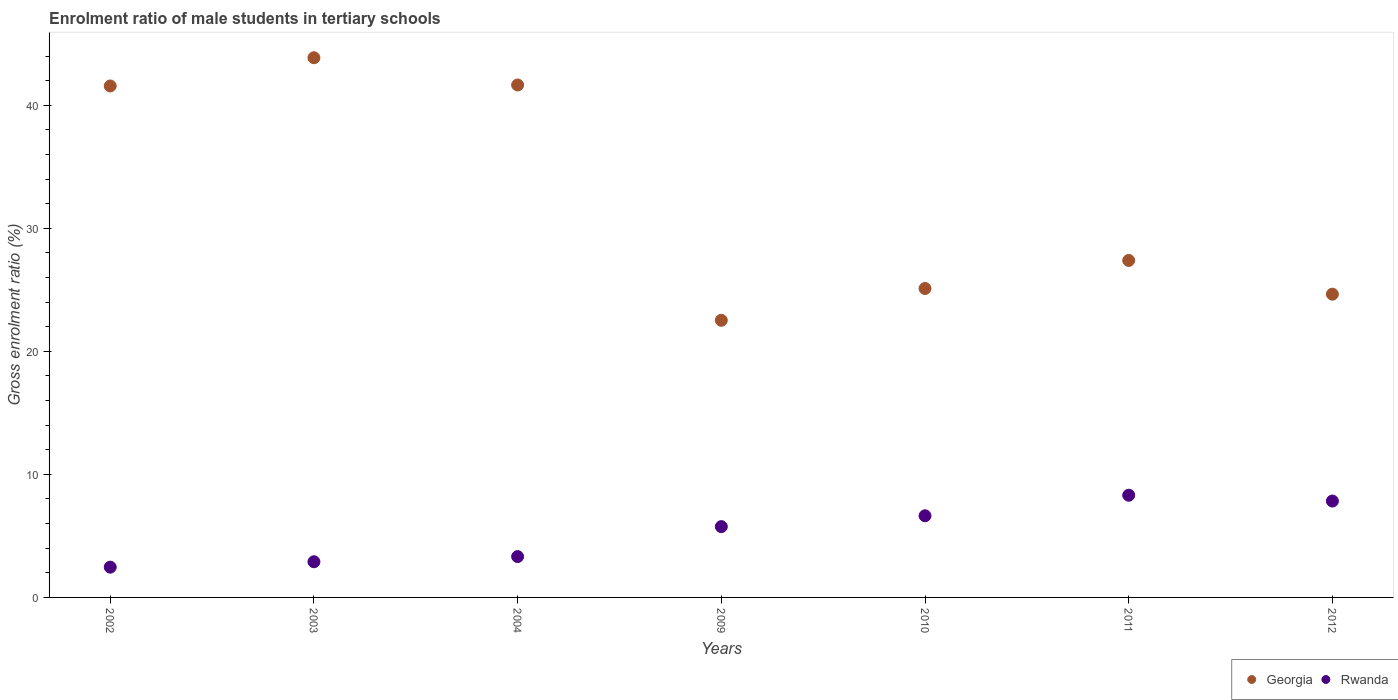How many different coloured dotlines are there?
Your answer should be compact. 2. What is the enrolment ratio of male students in tertiary schools in Rwanda in 2012?
Ensure brevity in your answer.  7.83. Across all years, what is the maximum enrolment ratio of male students in tertiary schools in Georgia?
Your answer should be compact. 43.86. Across all years, what is the minimum enrolment ratio of male students in tertiary schools in Rwanda?
Keep it short and to the point. 2.46. In which year was the enrolment ratio of male students in tertiary schools in Rwanda maximum?
Your answer should be compact. 2011. What is the total enrolment ratio of male students in tertiary schools in Georgia in the graph?
Make the answer very short. 226.74. What is the difference between the enrolment ratio of male students in tertiary schools in Georgia in 2010 and that in 2012?
Make the answer very short. 0.46. What is the difference between the enrolment ratio of male students in tertiary schools in Georgia in 2010 and the enrolment ratio of male students in tertiary schools in Rwanda in 2012?
Ensure brevity in your answer.  17.27. What is the average enrolment ratio of male students in tertiary schools in Georgia per year?
Offer a very short reply. 32.39. In the year 2011, what is the difference between the enrolment ratio of male students in tertiary schools in Rwanda and enrolment ratio of male students in tertiary schools in Georgia?
Keep it short and to the point. -19.08. In how many years, is the enrolment ratio of male students in tertiary schools in Georgia greater than 34 %?
Your response must be concise. 3. What is the ratio of the enrolment ratio of male students in tertiary schools in Georgia in 2003 to that in 2011?
Provide a short and direct response. 1.6. Is the enrolment ratio of male students in tertiary schools in Rwanda in 2003 less than that in 2012?
Provide a succinct answer. Yes. What is the difference between the highest and the second highest enrolment ratio of male students in tertiary schools in Georgia?
Your response must be concise. 2.22. What is the difference between the highest and the lowest enrolment ratio of male students in tertiary schools in Georgia?
Provide a short and direct response. 21.34. Is the enrolment ratio of male students in tertiary schools in Rwanda strictly less than the enrolment ratio of male students in tertiary schools in Georgia over the years?
Offer a terse response. Yes. How many dotlines are there?
Your response must be concise. 2. Are the values on the major ticks of Y-axis written in scientific E-notation?
Ensure brevity in your answer.  No. Does the graph contain grids?
Provide a succinct answer. No. Where does the legend appear in the graph?
Give a very brief answer. Bottom right. How many legend labels are there?
Provide a short and direct response. 2. What is the title of the graph?
Ensure brevity in your answer.  Enrolment ratio of male students in tertiary schools. Does "Tuvalu" appear as one of the legend labels in the graph?
Offer a terse response. No. What is the label or title of the X-axis?
Offer a terse response. Years. What is the label or title of the Y-axis?
Make the answer very short. Gross enrolment ratio (%). What is the Gross enrolment ratio (%) of Georgia in 2002?
Provide a short and direct response. 41.57. What is the Gross enrolment ratio (%) of Rwanda in 2002?
Provide a succinct answer. 2.46. What is the Gross enrolment ratio (%) of Georgia in 2003?
Give a very brief answer. 43.86. What is the Gross enrolment ratio (%) of Rwanda in 2003?
Your response must be concise. 2.9. What is the Gross enrolment ratio (%) in Georgia in 2004?
Offer a very short reply. 41.65. What is the Gross enrolment ratio (%) in Rwanda in 2004?
Offer a terse response. 3.32. What is the Gross enrolment ratio (%) in Georgia in 2009?
Provide a short and direct response. 22.52. What is the Gross enrolment ratio (%) of Rwanda in 2009?
Provide a succinct answer. 5.75. What is the Gross enrolment ratio (%) of Georgia in 2010?
Provide a short and direct response. 25.11. What is the Gross enrolment ratio (%) in Rwanda in 2010?
Provide a short and direct response. 6.64. What is the Gross enrolment ratio (%) of Georgia in 2011?
Give a very brief answer. 27.39. What is the Gross enrolment ratio (%) of Rwanda in 2011?
Your answer should be compact. 8.31. What is the Gross enrolment ratio (%) of Georgia in 2012?
Make the answer very short. 24.65. What is the Gross enrolment ratio (%) of Rwanda in 2012?
Ensure brevity in your answer.  7.83. Across all years, what is the maximum Gross enrolment ratio (%) of Georgia?
Provide a short and direct response. 43.86. Across all years, what is the maximum Gross enrolment ratio (%) in Rwanda?
Make the answer very short. 8.31. Across all years, what is the minimum Gross enrolment ratio (%) in Georgia?
Your response must be concise. 22.52. Across all years, what is the minimum Gross enrolment ratio (%) of Rwanda?
Ensure brevity in your answer.  2.46. What is the total Gross enrolment ratio (%) of Georgia in the graph?
Give a very brief answer. 226.74. What is the total Gross enrolment ratio (%) of Rwanda in the graph?
Give a very brief answer. 37.21. What is the difference between the Gross enrolment ratio (%) in Georgia in 2002 and that in 2003?
Your response must be concise. -2.3. What is the difference between the Gross enrolment ratio (%) in Rwanda in 2002 and that in 2003?
Your response must be concise. -0.44. What is the difference between the Gross enrolment ratio (%) in Georgia in 2002 and that in 2004?
Your answer should be very brief. -0.08. What is the difference between the Gross enrolment ratio (%) in Rwanda in 2002 and that in 2004?
Provide a short and direct response. -0.86. What is the difference between the Gross enrolment ratio (%) in Georgia in 2002 and that in 2009?
Make the answer very short. 19.04. What is the difference between the Gross enrolment ratio (%) in Rwanda in 2002 and that in 2009?
Provide a short and direct response. -3.29. What is the difference between the Gross enrolment ratio (%) in Georgia in 2002 and that in 2010?
Provide a succinct answer. 16.46. What is the difference between the Gross enrolment ratio (%) of Rwanda in 2002 and that in 2010?
Offer a terse response. -4.17. What is the difference between the Gross enrolment ratio (%) of Georgia in 2002 and that in 2011?
Provide a succinct answer. 14.18. What is the difference between the Gross enrolment ratio (%) of Rwanda in 2002 and that in 2011?
Your answer should be compact. -5.85. What is the difference between the Gross enrolment ratio (%) of Georgia in 2002 and that in 2012?
Provide a succinct answer. 16.92. What is the difference between the Gross enrolment ratio (%) of Rwanda in 2002 and that in 2012?
Offer a very short reply. -5.37. What is the difference between the Gross enrolment ratio (%) in Georgia in 2003 and that in 2004?
Give a very brief answer. 2.22. What is the difference between the Gross enrolment ratio (%) of Rwanda in 2003 and that in 2004?
Ensure brevity in your answer.  -0.42. What is the difference between the Gross enrolment ratio (%) in Georgia in 2003 and that in 2009?
Give a very brief answer. 21.34. What is the difference between the Gross enrolment ratio (%) in Rwanda in 2003 and that in 2009?
Give a very brief answer. -2.86. What is the difference between the Gross enrolment ratio (%) in Georgia in 2003 and that in 2010?
Keep it short and to the point. 18.76. What is the difference between the Gross enrolment ratio (%) of Rwanda in 2003 and that in 2010?
Your response must be concise. -3.74. What is the difference between the Gross enrolment ratio (%) of Georgia in 2003 and that in 2011?
Ensure brevity in your answer.  16.47. What is the difference between the Gross enrolment ratio (%) of Rwanda in 2003 and that in 2011?
Your answer should be very brief. -5.41. What is the difference between the Gross enrolment ratio (%) in Georgia in 2003 and that in 2012?
Give a very brief answer. 19.22. What is the difference between the Gross enrolment ratio (%) in Rwanda in 2003 and that in 2012?
Provide a short and direct response. -4.93. What is the difference between the Gross enrolment ratio (%) of Georgia in 2004 and that in 2009?
Keep it short and to the point. 19.12. What is the difference between the Gross enrolment ratio (%) in Rwanda in 2004 and that in 2009?
Make the answer very short. -2.44. What is the difference between the Gross enrolment ratio (%) in Georgia in 2004 and that in 2010?
Provide a succinct answer. 16.54. What is the difference between the Gross enrolment ratio (%) of Rwanda in 2004 and that in 2010?
Offer a terse response. -3.32. What is the difference between the Gross enrolment ratio (%) in Georgia in 2004 and that in 2011?
Your answer should be very brief. 14.26. What is the difference between the Gross enrolment ratio (%) in Rwanda in 2004 and that in 2011?
Provide a short and direct response. -4.99. What is the difference between the Gross enrolment ratio (%) of Georgia in 2004 and that in 2012?
Offer a very short reply. 17. What is the difference between the Gross enrolment ratio (%) in Rwanda in 2004 and that in 2012?
Your answer should be compact. -4.51. What is the difference between the Gross enrolment ratio (%) of Georgia in 2009 and that in 2010?
Give a very brief answer. -2.58. What is the difference between the Gross enrolment ratio (%) of Rwanda in 2009 and that in 2010?
Give a very brief answer. -0.88. What is the difference between the Gross enrolment ratio (%) in Georgia in 2009 and that in 2011?
Provide a succinct answer. -4.86. What is the difference between the Gross enrolment ratio (%) in Rwanda in 2009 and that in 2011?
Ensure brevity in your answer.  -2.55. What is the difference between the Gross enrolment ratio (%) of Georgia in 2009 and that in 2012?
Give a very brief answer. -2.12. What is the difference between the Gross enrolment ratio (%) of Rwanda in 2009 and that in 2012?
Keep it short and to the point. -2.08. What is the difference between the Gross enrolment ratio (%) of Georgia in 2010 and that in 2011?
Your answer should be very brief. -2.28. What is the difference between the Gross enrolment ratio (%) of Rwanda in 2010 and that in 2011?
Keep it short and to the point. -1.67. What is the difference between the Gross enrolment ratio (%) in Georgia in 2010 and that in 2012?
Your response must be concise. 0.46. What is the difference between the Gross enrolment ratio (%) in Rwanda in 2010 and that in 2012?
Your answer should be very brief. -1.2. What is the difference between the Gross enrolment ratio (%) of Georgia in 2011 and that in 2012?
Your answer should be compact. 2.74. What is the difference between the Gross enrolment ratio (%) of Rwanda in 2011 and that in 2012?
Offer a very short reply. 0.47. What is the difference between the Gross enrolment ratio (%) in Georgia in 2002 and the Gross enrolment ratio (%) in Rwanda in 2003?
Keep it short and to the point. 38.67. What is the difference between the Gross enrolment ratio (%) in Georgia in 2002 and the Gross enrolment ratio (%) in Rwanda in 2004?
Your answer should be very brief. 38.25. What is the difference between the Gross enrolment ratio (%) in Georgia in 2002 and the Gross enrolment ratio (%) in Rwanda in 2009?
Offer a terse response. 35.81. What is the difference between the Gross enrolment ratio (%) in Georgia in 2002 and the Gross enrolment ratio (%) in Rwanda in 2010?
Offer a very short reply. 34.93. What is the difference between the Gross enrolment ratio (%) in Georgia in 2002 and the Gross enrolment ratio (%) in Rwanda in 2011?
Provide a short and direct response. 33.26. What is the difference between the Gross enrolment ratio (%) in Georgia in 2002 and the Gross enrolment ratio (%) in Rwanda in 2012?
Your response must be concise. 33.73. What is the difference between the Gross enrolment ratio (%) of Georgia in 2003 and the Gross enrolment ratio (%) of Rwanda in 2004?
Offer a very short reply. 40.54. What is the difference between the Gross enrolment ratio (%) in Georgia in 2003 and the Gross enrolment ratio (%) in Rwanda in 2009?
Your response must be concise. 38.11. What is the difference between the Gross enrolment ratio (%) of Georgia in 2003 and the Gross enrolment ratio (%) of Rwanda in 2010?
Offer a terse response. 37.23. What is the difference between the Gross enrolment ratio (%) in Georgia in 2003 and the Gross enrolment ratio (%) in Rwanda in 2011?
Give a very brief answer. 35.56. What is the difference between the Gross enrolment ratio (%) of Georgia in 2003 and the Gross enrolment ratio (%) of Rwanda in 2012?
Make the answer very short. 36.03. What is the difference between the Gross enrolment ratio (%) of Georgia in 2004 and the Gross enrolment ratio (%) of Rwanda in 2009?
Make the answer very short. 35.89. What is the difference between the Gross enrolment ratio (%) in Georgia in 2004 and the Gross enrolment ratio (%) in Rwanda in 2010?
Give a very brief answer. 35.01. What is the difference between the Gross enrolment ratio (%) of Georgia in 2004 and the Gross enrolment ratio (%) of Rwanda in 2011?
Your response must be concise. 33.34. What is the difference between the Gross enrolment ratio (%) of Georgia in 2004 and the Gross enrolment ratio (%) of Rwanda in 2012?
Provide a short and direct response. 33.81. What is the difference between the Gross enrolment ratio (%) of Georgia in 2009 and the Gross enrolment ratio (%) of Rwanda in 2010?
Provide a short and direct response. 15.89. What is the difference between the Gross enrolment ratio (%) in Georgia in 2009 and the Gross enrolment ratio (%) in Rwanda in 2011?
Offer a terse response. 14.22. What is the difference between the Gross enrolment ratio (%) in Georgia in 2009 and the Gross enrolment ratio (%) in Rwanda in 2012?
Provide a succinct answer. 14.69. What is the difference between the Gross enrolment ratio (%) in Georgia in 2010 and the Gross enrolment ratio (%) in Rwanda in 2011?
Make the answer very short. 16.8. What is the difference between the Gross enrolment ratio (%) in Georgia in 2010 and the Gross enrolment ratio (%) in Rwanda in 2012?
Your answer should be compact. 17.27. What is the difference between the Gross enrolment ratio (%) of Georgia in 2011 and the Gross enrolment ratio (%) of Rwanda in 2012?
Ensure brevity in your answer.  19.55. What is the average Gross enrolment ratio (%) of Georgia per year?
Offer a terse response. 32.39. What is the average Gross enrolment ratio (%) of Rwanda per year?
Provide a succinct answer. 5.32. In the year 2002, what is the difference between the Gross enrolment ratio (%) in Georgia and Gross enrolment ratio (%) in Rwanda?
Offer a terse response. 39.11. In the year 2003, what is the difference between the Gross enrolment ratio (%) of Georgia and Gross enrolment ratio (%) of Rwanda?
Ensure brevity in your answer.  40.96. In the year 2004, what is the difference between the Gross enrolment ratio (%) in Georgia and Gross enrolment ratio (%) in Rwanda?
Your answer should be compact. 38.33. In the year 2009, what is the difference between the Gross enrolment ratio (%) in Georgia and Gross enrolment ratio (%) in Rwanda?
Ensure brevity in your answer.  16.77. In the year 2010, what is the difference between the Gross enrolment ratio (%) of Georgia and Gross enrolment ratio (%) of Rwanda?
Your answer should be very brief. 18.47. In the year 2011, what is the difference between the Gross enrolment ratio (%) of Georgia and Gross enrolment ratio (%) of Rwanda?
Ensure brevity in your answer.  19.08. In the year 2012, what is the difference between the Gross enrolment ratio (%) in Georgia and Gross enrolment ratio (%) in Rwanda?
Provide a short and direct response. 16.81. What is the ratio of the Gross enrolment ratio (%) in Georgia in 2002 to that in 2003?
Keep it short and to the point. 0.95. What is the ratio of the Gross enrolment ratio (%) of Rwanda in 2002 to that in 2003?
Offer a terse response. 0.85. What is the ratio of the Gross enrolment ratio (%) in Rwanda in 2002 to that in 2004?
Provide a short and direct response. 0.74. What is the ratio of the Gross enrolment ratio (%) of Georgia in 2002 to that in 2009?
Give a very brief answer. 1.85. What is the ratio of the Gross enrolment ratio (%) in Rwanda in 2002 to that in 2009?
Your answer should be very brief. 0.43. What is the ratio of the Gross enrolment ratio (%) in Georgia in 2002 to that in 2010?
Offer a very short reply. 1.66. What is the ratio of the Gross enrolment ratio (%) of Rwanda in 2002 to that in 2010?
Keep it short and to the point. 0.37. What is the ratio of the Gross enrolment ratio (%) of Georgia in 2002 to that in 2011?
Your answer should be very brief. 1.52. What is the ratio of the Gross enrolment ratio (%) of Rwanda in 2002 to that in 2011?
Provide a short and direct response. 0.3. What is the ratio of the Gross enrolment ratio (%) in Georgia in 2002 to that in 2012?
Make the answer very short. 1.69. What is the ratio of the Gross enrolment ratio (%) of Rwanda in 2002 to that in 2012?
Provide a succinct answer. 0.31. What is the ratio of the Gross enrolment ratio (%) in Georgia in 2003 to that in 2004?
Give a very brief answer. 1.05. What is the ratio of the Gross enrolment ratio (%) in Rwanda in 2003 to that in 2004?
Provide a short and direct response. 0.87. What is the ratio of the Gross enrolment ratio (%) in Georgia in 2003 to that in 2009?
Provide a short and direct response. 1.95. What is the ratio of the Gross enrolment ratio (%) in Rwanda in 2003 to that in 2009?
Your answer should be compact. 0.5. What is the ratio of the Gross enrolment ratio (%) of Georgia in 2003 to that in 2010?
Provide a short and direct response. 1.75. What is the ratio of the Gross enrolment ratio (%) of Rwanda in 2003 to that in 2010?
Your answer should be very brief. 0.44. What is the ratio of the Gross enrolment ratio (%) in Georgia in 2003 to that in 2011?
Your answer should be compact. 1.6. What is the ratio of the Gross enrolment ratio (%) in Rwanda in 2003 to that in 2011?
Ensure brevity in your answer.  0.35. What is the ratio of the Gross enrolment ratio (%) of Georgia in 2003 to that in 2012?
Your answer should be very brief. 1.78. What is the ratio of the Gross enrolment ratio (%) of Rwanda in 2003 to that in 2012?
Your answer should be very brief. 0.37. What is the ratio of the Gross enrolment ratio (%) in Georgia in 2004 to that in 2009?
Keep it short and to the point. 1.85. What is the ratio of the Gross enrolment ratio (%) of Rwanda in 2004 to that in 2009?
Provide a succinct answer. 0.58. What is the ratio of the Gross enrolment ratio (%) in Georgia in 2004 to that in 2010?
Your response must be concise. 1.66. What is the ratio of the Gross enrolment ratio (%) of Rwanda in 2004 to that in 2010?
Your response must be concise. 0.5. What is the ratio of the Gross enrolment ratio (%) of Georgia in 2004 to that in 2011?
Give a very brief answer. 1.52. What is the ratio of the Gross enrolment ratio (%) of Rwanda in 2004 to that in 2011?
Provide a succinct answer. 0.4. What is the ratio of the Gross enrolment ratio (%) in Georgia in 2004 to that in 2012?
Give a very brief answer. 1.69. What is the ratio of the Gross enrolment ratio (%) in Rwanda in 2004 to that in 2012?
Give a very brief answer. 0.42. What is the ratio of the Gross enrolment ratio (%) of Georgia in 2009 to that in 2010?
Your answer should be very brief. 0.9. What is the ratio of the Gross enrolment ratio (%) of Rwanda in 2009 to that in 2010?
Your answer should be compact. 0.87. What is the ratio of the Gross enrolment ratio (%) in Georgia in 2009 to that in 2011?
Offer a terse response. 0.82. What is the ratio of the Gross enrolment ratio (%) of Rwanda in 2009 to that in 2011?
Provide a short and direct response. 0.69. What is the ratio of the Gross enrolment ratio (%) in Georgia in 2009 to that in 2012?
Give a very brief answer. 0.91. What is the ratio of the Gross enrolment ratio (%) in Rwanda in 2009 to that in 2012?
Make the answer very short. 0.73. What is the ratio of the Gross enrolment ratio (%) of Georgia in 2010 to that in 2011?
Offer a very short reply. 0.92. What is the ratio of the Gross enrolment ratio (%) in Rwanda in 2010 to that in 2011?
Offer a terse response. 0.8. What is the ratio of the Gross enrolment ratio (%) of Georgia in 2010 to that in 2012?
Provide a short and direct response. 1.02. What is the ratio of the Gross enrolment ratio (%) in Rwanda in 2010 to that in 2012?
Give a very brief answer. 0.85. What is the ratio of the Gross enrolment ratio (%) in Georgia in 2011 to that in 2012?
Give a very brief answer. 1.11. What is the ratio of the Gross enrolment ratio (%) of Rwanda in 2011 to that in 2012?
Your response must be concise. 1.06. What is the difference between the highest and the second highest Gross enrolment ratio (%) of Georgia?
Give a very brief answer. 2.22. What is the difference between the highest and the second highest Gross enrolment ratio (%) in Rwanda?
Ensure brevity in your answer.  0.47. What is the difference between the highest and the lowest Gross enrolment ratio (%) in Georgia?
Provide a succinct answer. 21.34. What is the difference between the highest and the lowest Gross enrolment ratio (%) of Rwanda?
Provide a short and direct response. 5.85. 